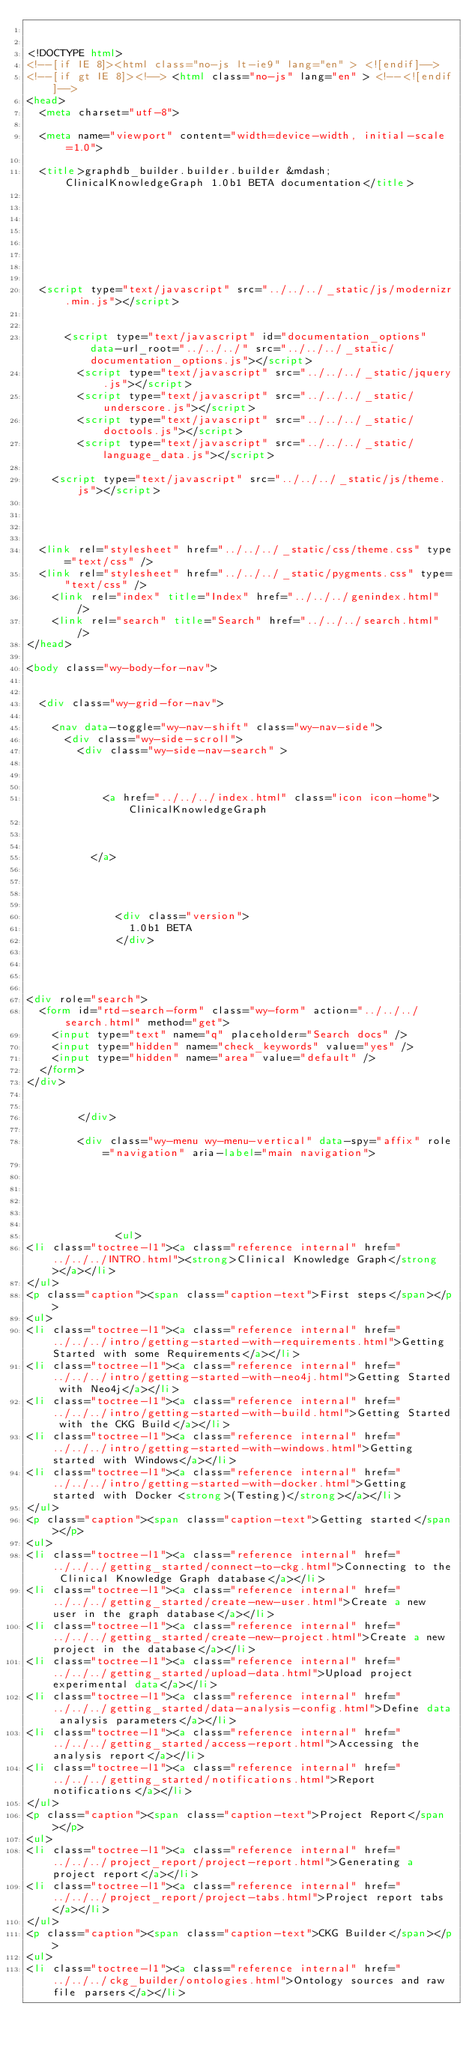<code> <loc_0><loc_0><loc_500><loc_500><_HTML_>

<!DOCTYPE html>
<!--[if IE 8]><html class="no-js lt-ie9" lang="en" > <![endif]-->
<!--[if gt IE 8]><!--> <html class="no-js" lang="en" > <!--<![endif]-->
<head>
  <meta charset="utf-8">
  
  <meta name="viewport" content="width=device-width, initial-scale=1.0">
  
  <title>graphdb_builder.builder.builder &mdash; ClinicalKnowledgeGraph 1.0b1 BETA documentation</title>
  

  
  
  
  

  
  <script type="text/javascript" src="../../../_static/js/modernizr.min.js"></script>
  
    
      <script type="text/javascript" id="documentation_options" data-url_root="../../../" src="../../../_static/documentation_options.js"></script>
        <script type="text/javascript" src="../../../_static/jquery.js"></script>
        <script type="text/javascript" src="../../../_static/underscore.js"></script>
        <script type="text/javascript" src="../../../_static/doctools.js"></script>
        <script type="text/javascript" src="../../../_static/language_data.js"></script>
    
    <script type="text/javascript" src="../../../_static/js/theme.js"></script>

    

  
  <link rel="stylesheet" href="../../../_static/css/theme.css" type="text/css" />
  <link rel="stylesheet" href="../../../_static/pygments.css" type="text/css" />
    <link rel="index" title="Index" href="../../../genindex.html" />
    <link rel="search" title="Search" href="../../../search.html" /> 
</head>

<body class="wy-body-for-nav">

   
  <div class="wy-grid-for-nav">
    
    <nav data-toggle="wy-nav-shift" class="wy-nav-side">
      <div class="wy-side-scroll">
        <div class="wy-side-nav-search" >
          

          
            <a href="../../../index.html" class="icon icon-home"> ClinicalKnowledgeGraph
          

          
          </a>

          
            
            
              <div class="version">
                1.0b1 BETA
              </div>
            
          

          
<div role="search">
  <form id="rtd-search-form" class="wy-form" action="../../../search.html" method="get">
    <input type="text" name="q" placeholder="Search docs" />
    <input type="hidden" name="check_keywords" value="yes" />
    <input type="hidden" name="area" value="default" />
  </form>
</div>

          
        </div>

        <div class="wy-menu wy-menu-vertical" data-spy="affix" role="navigation" aria-label="main navigation">
          
            
            
              
            
            
              <ul>
<li class="toctree-l1"><a class="reference internal" href="../../../INTRO.html"><strong>Clinical Knowledge Graph</strong></a></li>
</ul>
<p class="caption"><span class="caption-text">First steps</span></p>
<ul>
<li class="toctree-l1"><a class="reference internal" href="../../../intro/getting-started-with-requirements.html">Getting Started with some Requirements</a></li>
<li class="toctree-l1"><a class="reference internal" href="../../../intro/getting-started-with-neo4j.html">Getting Started with Neo4j</a></li>
<li class="toctree-l1"><a class="reference internal" href="../../../intro/getting-started-with-build.html">Getting Started with the CKG Build</a></li>
<li class="toctree-l1"><a class="reference internal" href="../../../intro/getting-started-with-windows.html">Getting started with Windows</a></li>
<li class="toctree-l1"><a class="reference internal" href="../../../intro/getting-started-with-docker.html">Getting started with Docker <strong>(Testing)</strong></a></li>
</ul>
<p class="caption"><span class="caption-text">Getting started</span></p>
<ul>
<li class="toctree-l1"><a class="reference internal" href="../../../getting_started/connect-to-ckg.html">Connecting to the Clinical Knowledge Graph database</a></li>
<li class="toctree-l1"><a class="reference internal" href="../../../getting_started/create-new-user.html">Create a new user in the graph database</a></li>
<li class="toctree-l1"><a class="reference internal" href="../../../getting_started/create-new-project.html">Create a new project in the database</a></li>
<li class="toctree-l1"><a class="reference internal" href="../../../getting_started/upload-data.html">Upload project experimental data</a></li>
<li class="toctree-l1"><a class="reference internal" href="../../../getting_started/data-analysis-config.html">Define data analysis parameters</a></li>
<li class="toctree-l1"><a class="reference internal" href="../../../getting_started/access-report.html">Accessing the analysis report</a></li>
<li class="toctree-l1"><a class="reference internal" href="../../../getting_started/notifications.html">Report notifications</a></li>
</ul>
<p class="caption"><span class="caption-text">Project Report</span></p>
<ul>
<li class="toctree-l1"><a class="reference internal" href="../../../project_report/project-report.html">Generating a project report</a></li>
<li class="toctree-l1"><a class="reference internal" href="../../../project_report/project-tabs.html">Project report tabs</a></li>
</ul>
<p class="caption"><span class="caption-text">CKG Builder</span></p>
<ul>
<li class="toctree-l1"><a class="reference internal" href="../../../ckg_builder/ontologies.html">Ontology sources and raw file parsers</a></li></code> 